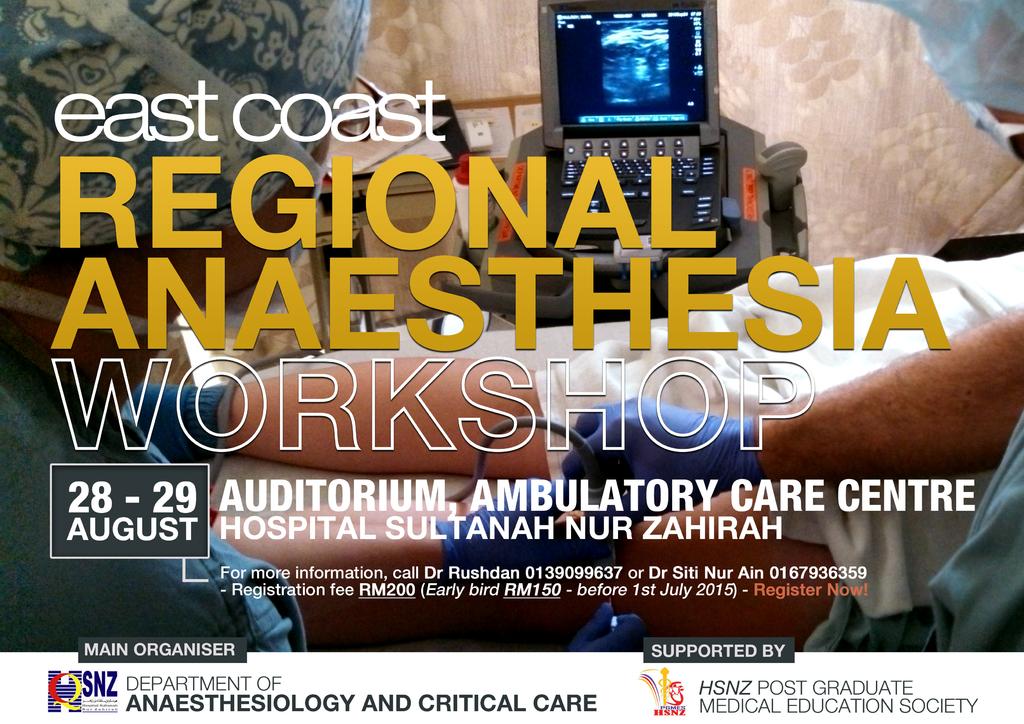What are the days this workshop is being hosted?
Your answer should be very brief. August 28-29. Who is this supported by?
Offer a very short reply. Hsnz post graduate medical education society. 